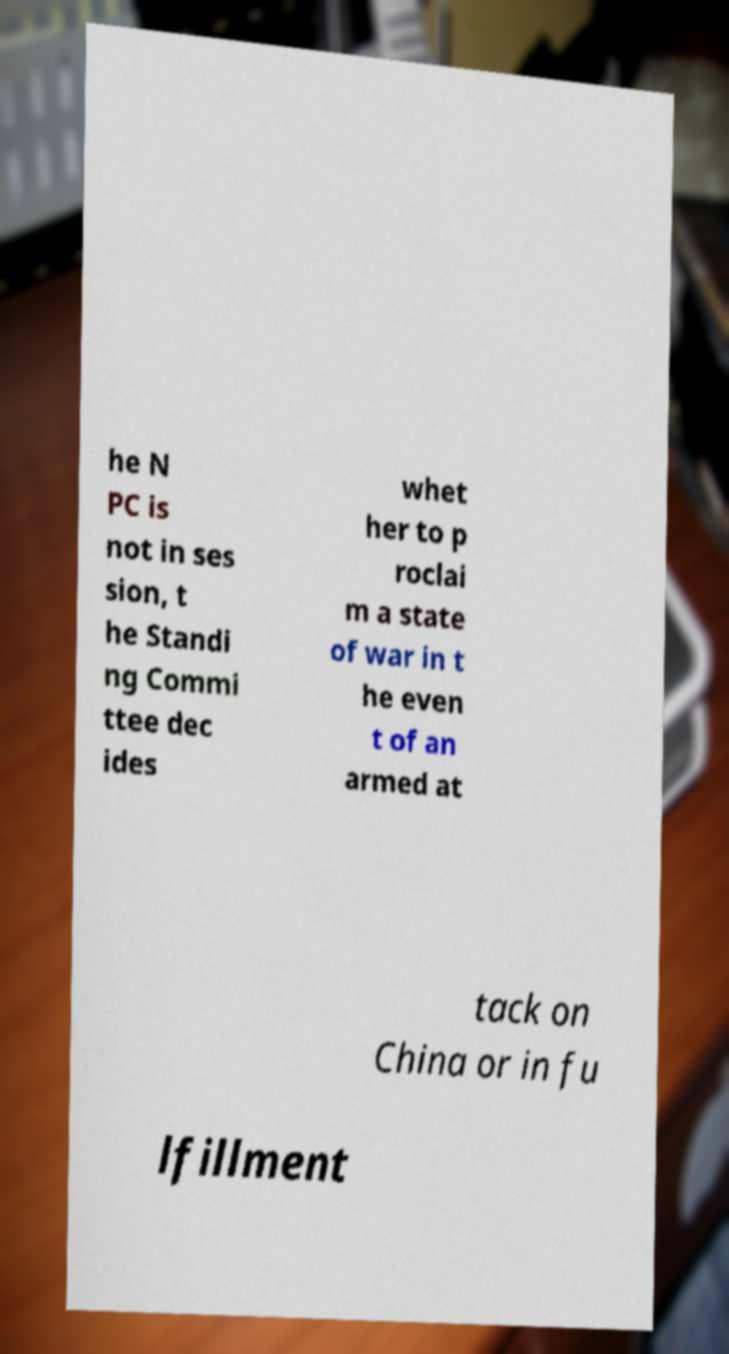Please identify and transcribe the text found in this image. he N PC is not in ses sion, t he Standi ng Commi ttee dec ides whet her to p roclai m a state of war in t he even t of an armed at tack on China or in fu lfillment 